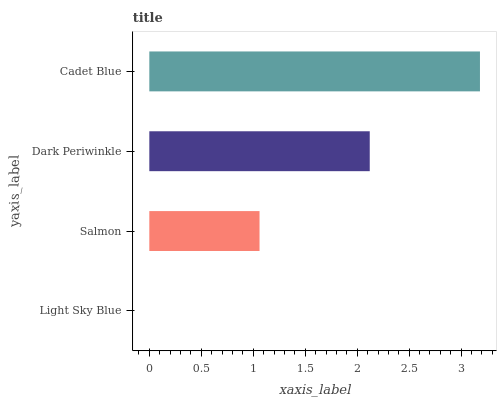Is Light Sky Blue the minimum?
Answer yes or no. Yes. Is Cadet Blue the maximum?
Answer yes or no. Yes. Is Salmon the minimum?
Answer yes or no. No. Is Salmon the maximum?
Answer yes or no. No. Is Salmon greater than Light Sky Blue?
Answer yes or no. Yes. Is Light Sky Blue less than Salmon?
Answer yes or no. Yes. Is Light Sky Blue greater than Salmon?
Answer yes or no. No. Is Salmon less than Light Sky Blue?
Answer yes or no. No. Is Dark Periwinkle the high median?
Answer yes or no. Yes. Is Salmon the low median?
Answer yes or no. Yes. Is Salmon the high median?
Answer yes or no. No. Is Cadet Blue the low median?
Answer yes or no. No. 